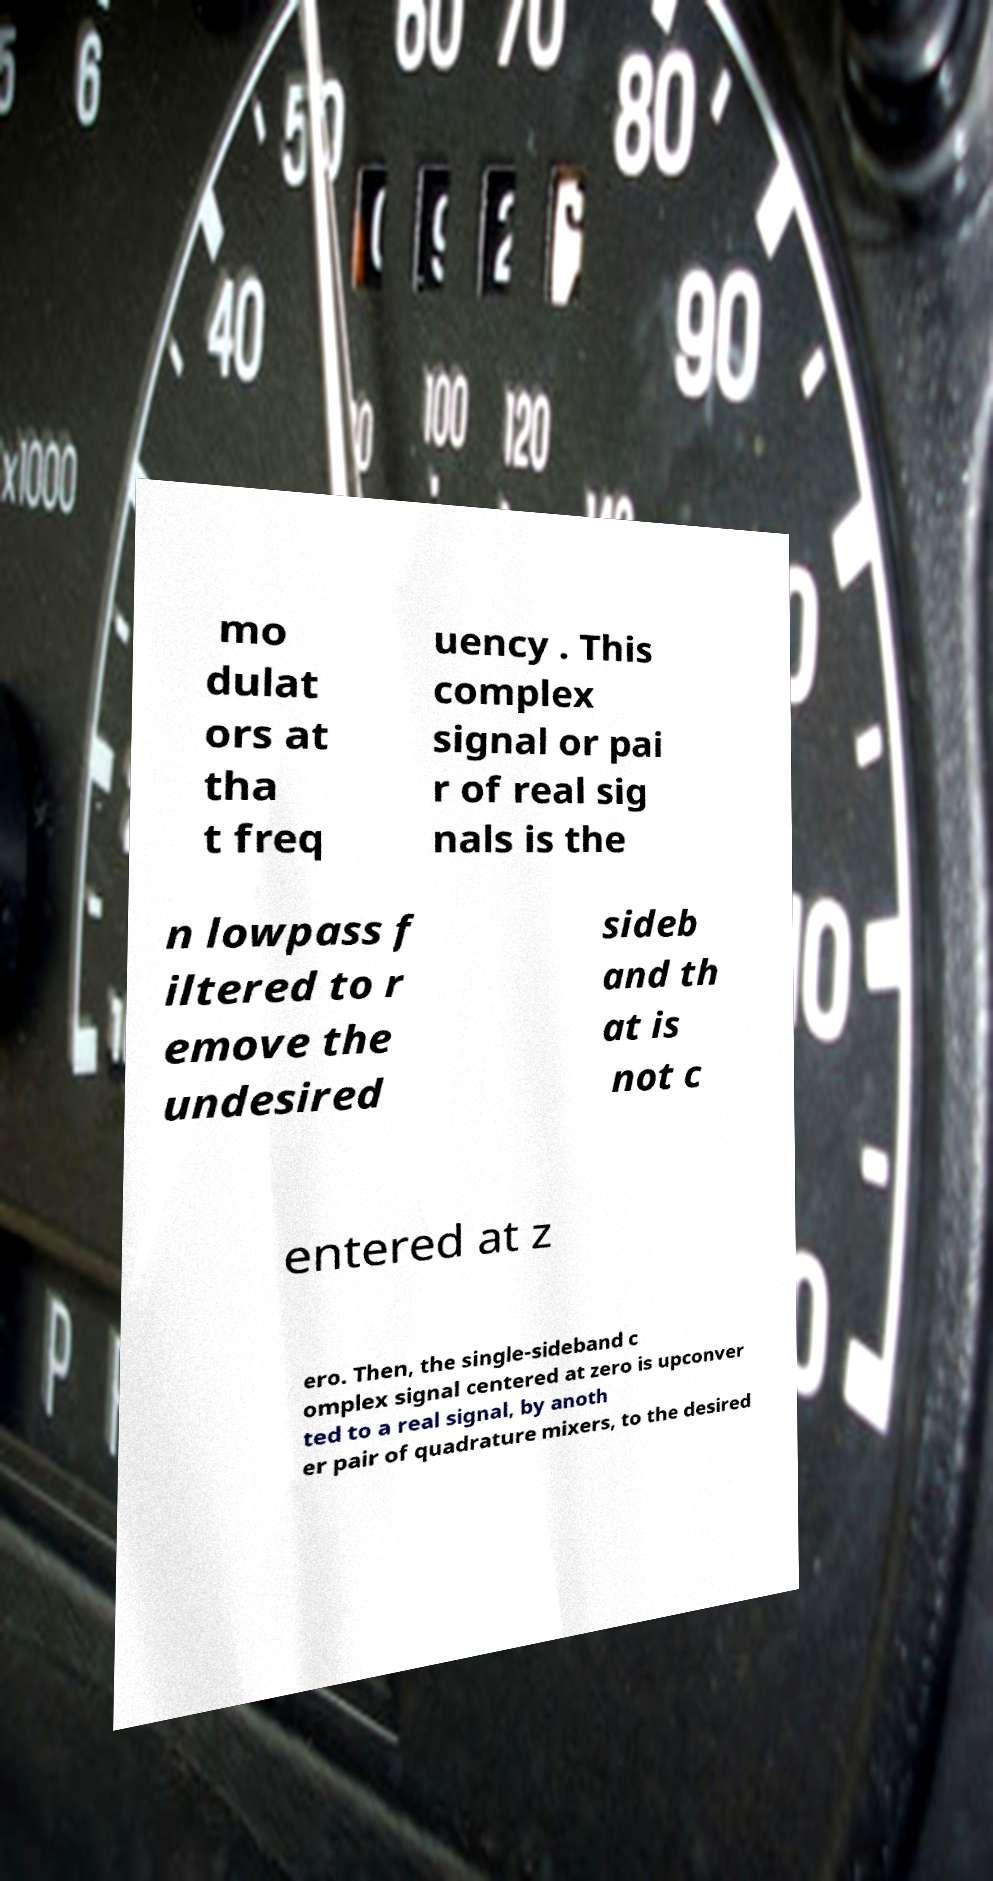Can you read and provide the text displayed in the image?This photo seems to have some interesting text. Can you extract and type it out for me? mo dulat ors at tha t freq uency . This complex signal or pai r of real sig nals is the n lowpass f iltered to r emove the undesired sideb and th at is not c entered at z ero. Then, the single-sideband c omplex signal centered at zero is upconver ted to a real signal, by anoth er pair of quadrature mixers, to the desired 